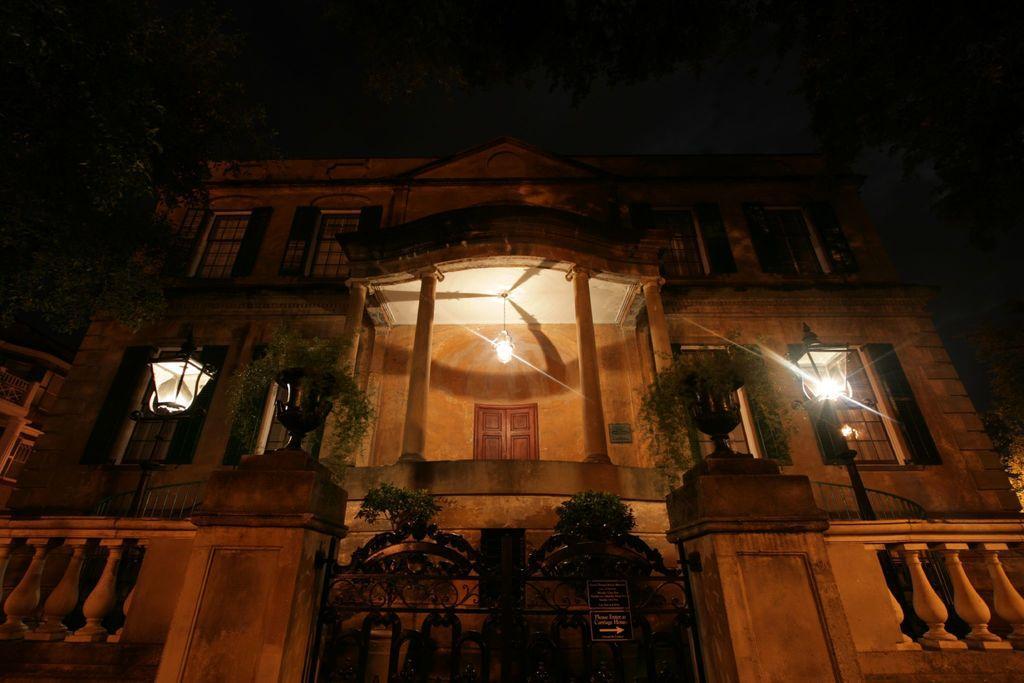Could you give a brief overview of what you see in this image? This image consists of building. There are plants in the middle. There are lights in the middle. It has windows. 